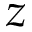Convert formula to latex. <formula><loc_0><loc_0><loc_500><loc_500>z</formula> 